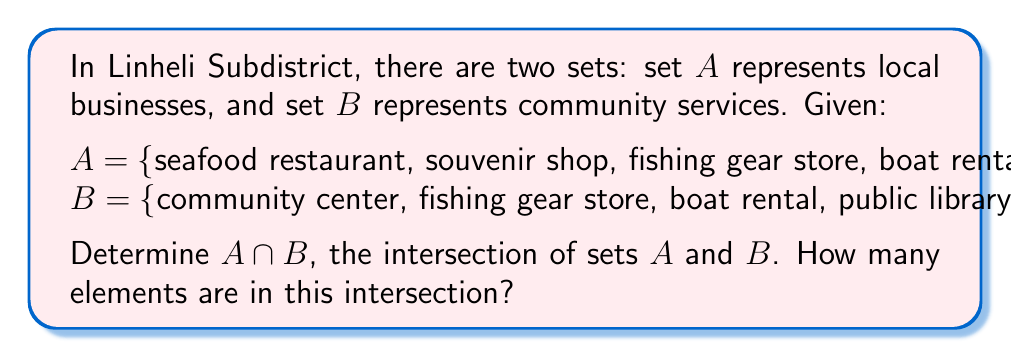Teach me how to tackle this problem. To solve this problem, we need to follow these steps:

1) Recall that the intersection of two sets, denoted as $A \cap B$, is the set of all elements that are common to both $A$ and $B$.

2) Let's list out the elements of each set:
   
   $A = \{\text{seafood restaurant, souvenir shop, fishing gear store, boat rental}\}$
   $B = \{\text{community center, fishing gear store, boat rental, public library}\}$

3) Now, we need to identify which elements appear in both sets:
   
   - "fishing gear store" appears in both $A$ and $B$
   - "boat rental" appears in both $A$ and $B$

4) Therefore, the intersection $A \cap B$ is:

   $A \cap B = \{\text{fishing gear store, boat rental}\}$

5) To count the number of elements in this intersection, we simply count the elements in the resulting set.

   $|A \cap B| = 2$

This intersection showcases the overlap between local businesses and community services in Linheli Subdistrict, highlighting the importance of fishing and boating to the community.
Answer: $A \cap B = \{\text{fishing gear store, boat rental}\}$

The number of elements in the intersection is 2. 